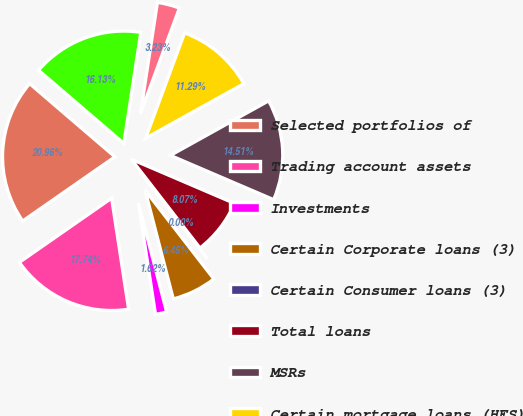Convert chart to OTSL. <chart><loc_0><loc_0><loc_500><loc_500><pie_chart><fcel>Selected portfolios of<fcel>Trading account assets<fcel>Investments<fcel>Certain Corporate loans (3)<fcel>Certain Consumer loans (3)<fcel>Total loans<fcel>MSRs<fcel>Certain mortgage loans (HFS)<fcel>Certain equity method<fcel>Total other assets<nl><fcel>20.96%<fcel>17.74%<fcel>1.62%<fcel>6.45%<fcel>0.0%<fcel>8.07%<fcel>14.51%<fcel>11.29%<fcel>3.23%<fcel>16.13%<nl></chart> 